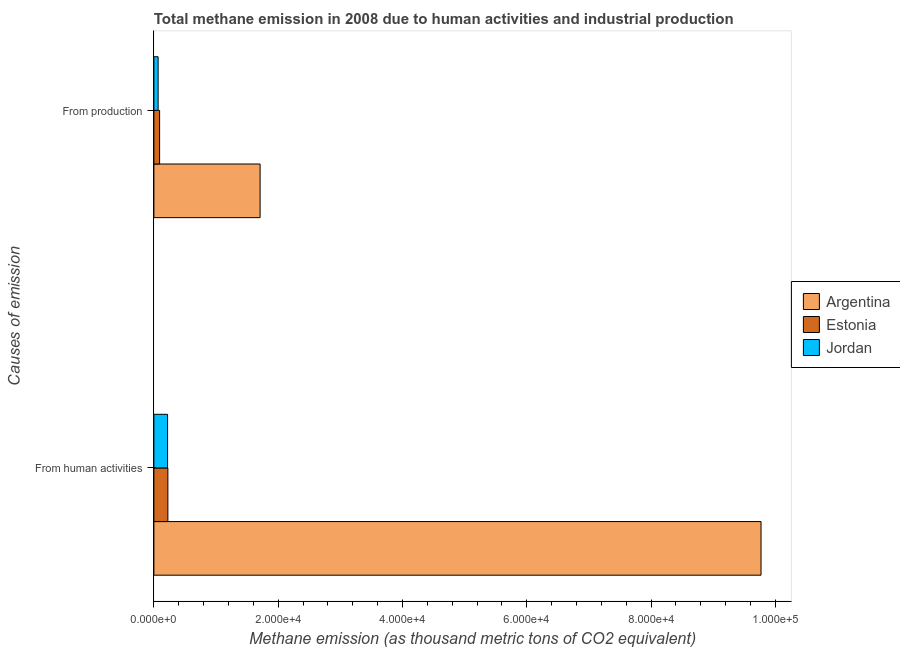How many different coloured bars are there?
Provide a short and direct response. 3. How many groups of bars are there?
Provide a succinct answer. 2. How many bars are there on the 2nd tick from the top?
Your answer should be very brief. 3. What is the label of the 1st group of bars from the top?
Ensure brevity in your answer.  From production. What is the amount of emissions generated from industries in Argentina?
Offer a terse response. 1.71e+04. Across all countries, what is the maximum amount of emissions from human activities?
Offer a terse response. 9.77e+04. Across all countries, what is the minimum amount of emissions generated from industries?
Your response must be concise. 681.7. In which country was the amount of emissions from human activities minimum?
Keep it short and to the point. Jordan. What is the total amount of emissions generated from industries in the graph?
Your response must be concise. 1.87e+04. What is the difference between the amount of emissions generated from industries in Jordan and that in Argentina?
Offer a very short reply. -1.64e+04. What is the difference between the amount of emissions generated from industries in Argentina and the amount of emissions from human activities in Jordan?
Offer a terse response. 1.49e+04. What is the average amount of emissions from human activities per country?
Offer a terse response. 3.41e+04. What is the difference between the amount of emissions generated from industries and amount of emissions from human activities in Estonia?
Your answer should be compact. -1330.3. In how many countries, is the amount of emissions generated from industries greater than 12000 thousand metric tons?
Give a very brief answer. 1. What is the ratio of the amount of emissions from human activities in Estonia to that in Jordan?
Offer a terse response. 1.02. Is the amount of emissions generated from industries in Estonia less than that in Jordan?
Offer a terse response. No. In how many countries, is the amount of emissions from human activities greater than the average amount of emissions from human activities taken over all countries?
Your answer should be very brief. 1. What does the 1st bar from the top in From production represents?
Give a very brief answer. Jordan. What does the 3rd bar from the bottom in From human activities represents?
Your answer should be very brief. Jordan. How many bars are there?
Provide a short and direct response. 6. How many countries are there in the graph?
Keep it short and to the point. 3. Does the graph contain any zero values?
Make the answer very short. No. Does the graph contain grids?
Provide a succinct answer. No. How are the legend labels stacked?
Make the answer very short. Vertical. What is the title of the graph?
Give a very brief answer. Total methane emission in 2008 due to human activities and industrial production. Does "Malta" appear as one of the legend labels in the graph?
Offer a terse response. No. What is the label or title of the X-axis?
Your response must be concise. Methane emission (as thousand metric tons of CO2 equivalent). What is the label or title of the Y-axis?
Keep it short and to the point. Causes of emission. What is the Methane emission (as thousand metric tons of CO2 equivalent) of Argentina in From human activities?
Provide a short and direct response. 9.77e+04. What is the Methane emission (as thousand metric tons of CO2 equivalent) of Estonia in From human activities?
Offer a terse response. 2252. What is the Methane emission (as thousand metric tons of CO2 equivalent) of Jordan in From human activities?
Your answer should be very brief. 2204.6. What is the Methane emission (as thousand metric tons of CO2 equivalent) of Argentina in From production?
Provide a succinct answer. 1.71e+04. What is the Methane emission (as thousand metric tons of CO2 equivalent) of Estonia in From production?
Provide a succinct answer. 921.7. What is the Methane emission (as thousand metric tons of CO2 equivalent) in Jordan in From production?
Make the answer very short. 681.7. Across all Causes of emission, what is the maximum Methane emission (as thousand metric tons of CO2 equivalent) in Argentina?
Your response must be concise. 9.77e+04. Across all Causes of emission, what is the maximum Methane emission (as thousand metric tons of CO2 equivalent) in Estonia?
Your answer should be very brief. 2252. Across all Causes of emission, what is the maximum Methane emission (as thousand metric tons of CO2 equivalent) in Jordan?
Make the answer very short. 2204.6. Across all Causes of emission, what is the minimum Methane emission (as thousand metric tons of CO2 equivalent) in Argentina?
Offer a very short reply. 1.71e+04. Across all Causes of emission, what is the minimum Methane emission (as thousand metric tons of CO2 equivalent) in Estonia?
Offer a very short reply. 921.7. Across all Causes of emission, what is the minimum Methane emission (as thousand metric tons of CO2 equivalent) in Jordan?
Your response must be concise. 681.7. What is the total Methane emission (as thousand metric tons of CO2 equivalent) in Argentina in the graph?
Make the answer very short. 1.15e+05. What is the total Methane emission (as thousand metric tons of CO2 equivalent) in Estonia in the graph?
Give a very brief answer. 3173.7. What is the total Methane emission (as thousand metric tons of CO2 equivalent) of Jordan in the graph?
Provide a short and direct response. 2886.3. What is the difference between the Methane emission (as thousand metric tons of CO2 equivalent) in Argentina in From human activities and that in From production?
Give a very brief answer. 8.06e+04. What is the difference between the Methane emission (as thousand metric tons of CO2 equivalent) in Estonia in From human activities and that in From production?
Keep it short and to the point. 1330.3. What is the difference between the Methane emission (as thousand metric tons of CO2 equivalent) of Jordan in From human activities and that in From production?
Your answer should be compact. 1522.9. What is the difference between the Methane emission (as thousand metric tons of CO2 equivalent) in Argentina in From human activities and the Methane emission (as thousand metric tons of CO2 equivalent) in Estonia in From production?
Provide a succinct answer. 9.68e+04. What is the difference between the Methane emission (as thousand metric tons of CO2 equivalent) of Argentina in From human activities and the Methane emission (as thousand metric tons of CO2 equivalent) of Jordan in From production?
Offer a very short reply. 9.70e+04. What is the difference between the Methane emission (as thousand metric tons of CO2 equivalent) in Estonia in From human activities and the Methane emission (as thousand metric tons of CO2 equivalent) in Jordan in From production?
Your answer should be very brief. 1570.3. What is the average Methane emission (as thousand metric tons of CO2 equivalent) in Argentina per Causes of emission?
Your answer should be compact. 5.74e+04. What is the average Methane emission (as thousand metric tons of CO2 equivalent) in Estonia per Causes of emission?
Keep it short and to the point. 1586.85. What is the average Methane emission (as thousand metric tons of CO2 equivalent) in Jordan per Causes of emission?
Keep it short and to the point. 1443.15. What is the difference between the Methane emission (as thousand metric tons of CO2 equivalent) of Argentina and Methane emission (as thousand metric tons of CO2 equivalent) of Estonia in From human activities?
Your response must be concise. 9.55e+04. What is the difference between the Methane emission (as thousand metric tons of CO2 equivalent) in Argentina and Methane emission (as thousand metric tons of CO2 equivalent) in Jordan in From human activities?
Your answer should be very brief. 9.55e+04. What is the difference between the Methane emission (as thousand metric tons of CO2 equivalent) of Estonia and Methane emission (as thousand metric tons of CO2 equivalent) of Jordan in From human activities?
Ensure brevity in your answer.  47.4. What is the difference between the Methane emission (as thousand metric tons of CO2 equivalent) in Argentina and Methane emission (as thousand metric tons of CO2 equivalent) in Estonia in From production?
Provide a succinct answer. 1.62e+04. What is the difference between the Methane emission (as thousand metric tons of CO2 equivalent) in Argentina and Methane emission (as thousand metric tons of CO2 equivalent) in Jordan in From production?
Provide a succinct answer. 1.64e+04. What is the difference between the Methane emission (as thousand metric tons of CO2 equivalent) in Estonia and Methane emission (as thousand metric tons of CO2 equivalent) in Jordan in From production?
Give a very brief answer. 240. What is the ratio of the Methane emission (as thousand metric tons of CO2 equivalent) in Argentina in From human activities to that in From production?
Provide a short and direct response. 5.72. What is the ratio of the Methane emission (as thousand metric tons of CO2 equivalent) of Estonia in From human activities to that in From production?
Make the answer very short. 2.44. What is the ratio of the Methane emission (as thousand metric tons of CO2 equivalent) in Jordan in From human activities to that in From production?
Provide a succinct answer. 3.23. What is the difference between the highest and the second highest Methane emission (as thousand metric tons of CO2 equivalent) in Argentina?
Offer a very short reply. 8.06e+04. What is the difference between the highest and the second highest Methane emission (as thousand metric tons of CO2 equivalent) of Estonia?
Your response must be concise. 1330.3. What is the difference between the highest and the second highest Methane emission (as thousand metric tons of CO2 equivalent) in Jordan?
Give a very brief answer. 1522.9. What is the difference between the highest and the lowest Methane emission (as thousand metric tons of CO2 equivalent) in Argentina?
Your answer should be very brief. 8.06e+04. What is the difference between the highest and the lowest Methane emission (as thousand metric tons of CO2 equivalent) of Estonia?
Your answer should be compact. 1330.3. What is the difference between the highest and the lowest Methane emission (as thousand metric tons of CO2 equivalent) of Jordan?
Your answer should be very brief. 1522.9. 